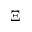Convert formula to latex. <formula><loc_0><loc_0><loc_500><loc_500>\Xi</formula> 